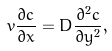<formula> <loc_0><loc_0><loc_500><loc_500>v \frac { \partial c } { \partial x } = D \frac { \partial ^ { 2 } c } { \partial y ^ { 2 } } ,</formula> 